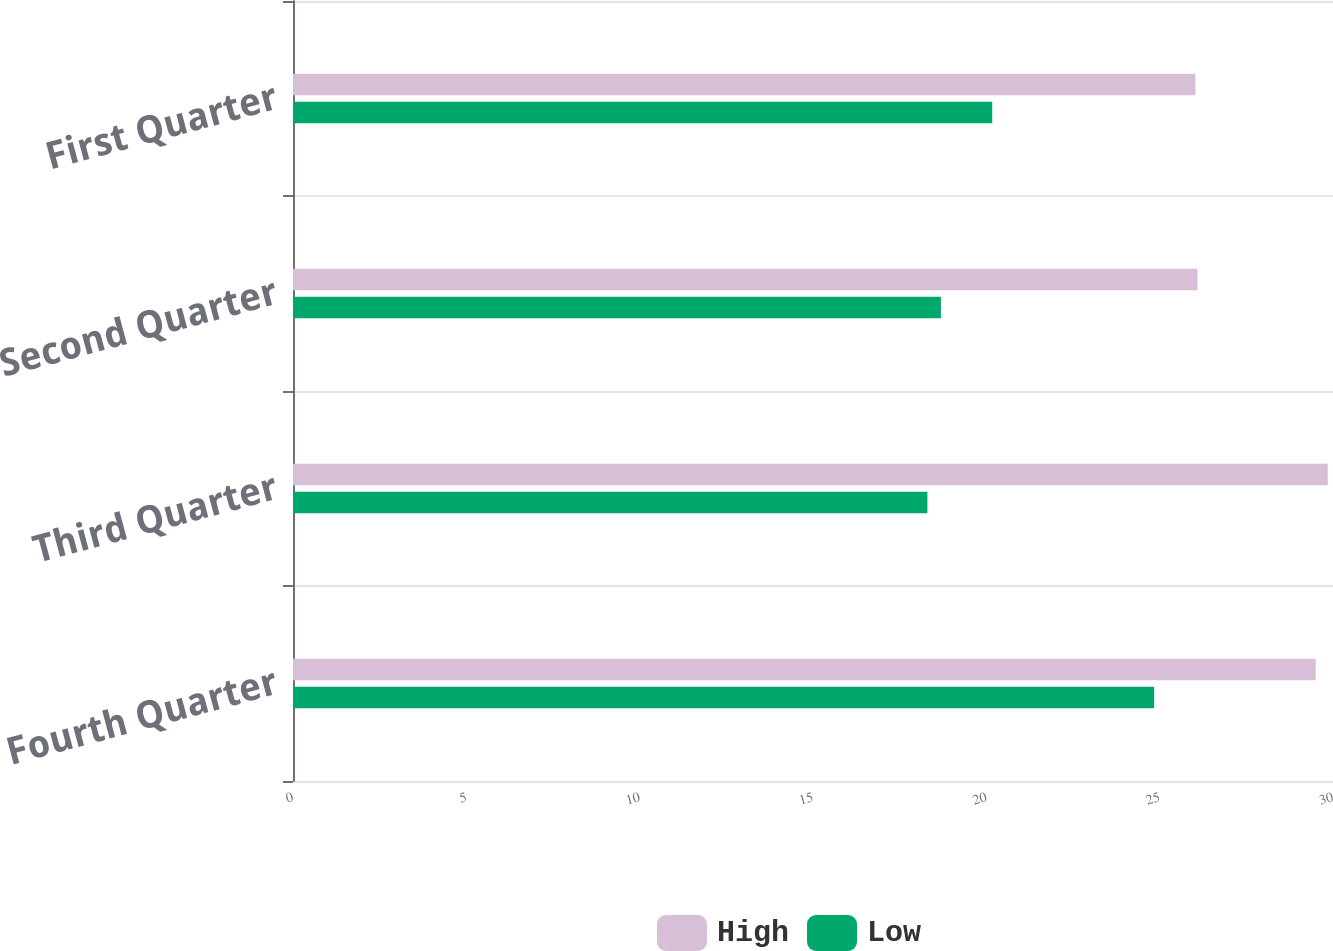Convert chart. <chart><loc_0><loc_0><loc_500><loc_500><stacked_bar_chart><ecel><fcel>Fourth Quarter<fcel>Third Quarter<fcel>Second Quarter<fcel>First Quarter<nl><fcel>High<fcel>29.5<fcel>29.85<fcel>26.09<fcel>26.03<nl><fcel>Low<fcel>24.84<fcel>18.3<fcel>18.69<fcel>20.17<nl></chart> 